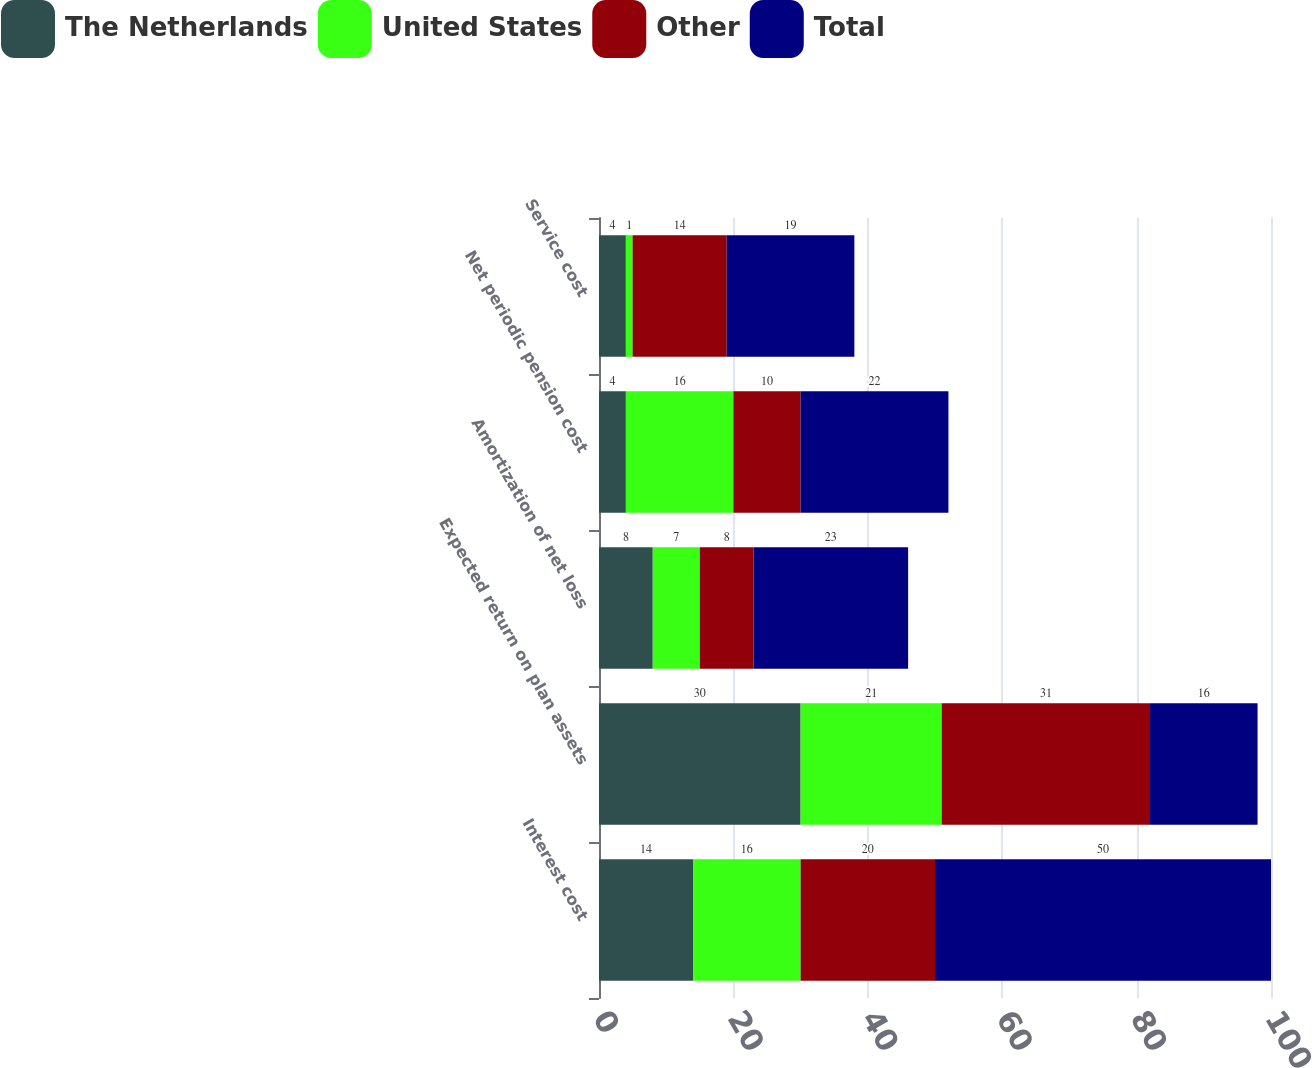Convert chart to OTSL. <chart><loc_0><loc_0><loc_500><loc_500><stacked_bar_chart><ecel><fcel>Interest cost<fcel>Expected return on plan assets<fcel>Amortization of net loss<fcel>Net periodic pension cost<fcel>Service cost<nl><fcel>The Netherlands<fcel>14<fcel>30<fcel>8<fcel>4<fcel>4<nl><fcel>United States<fcel>16<fcel>21<fcel>7<fcel>16<fcel>1<nl><fcel>Other<fcel>20<fcel>31<fcel>8<fcel>10<fcel>14<nl><fcel>Total<fcel>50<fcel>16<fcel>23<fcel>22<fcel>19<nl></chart> 